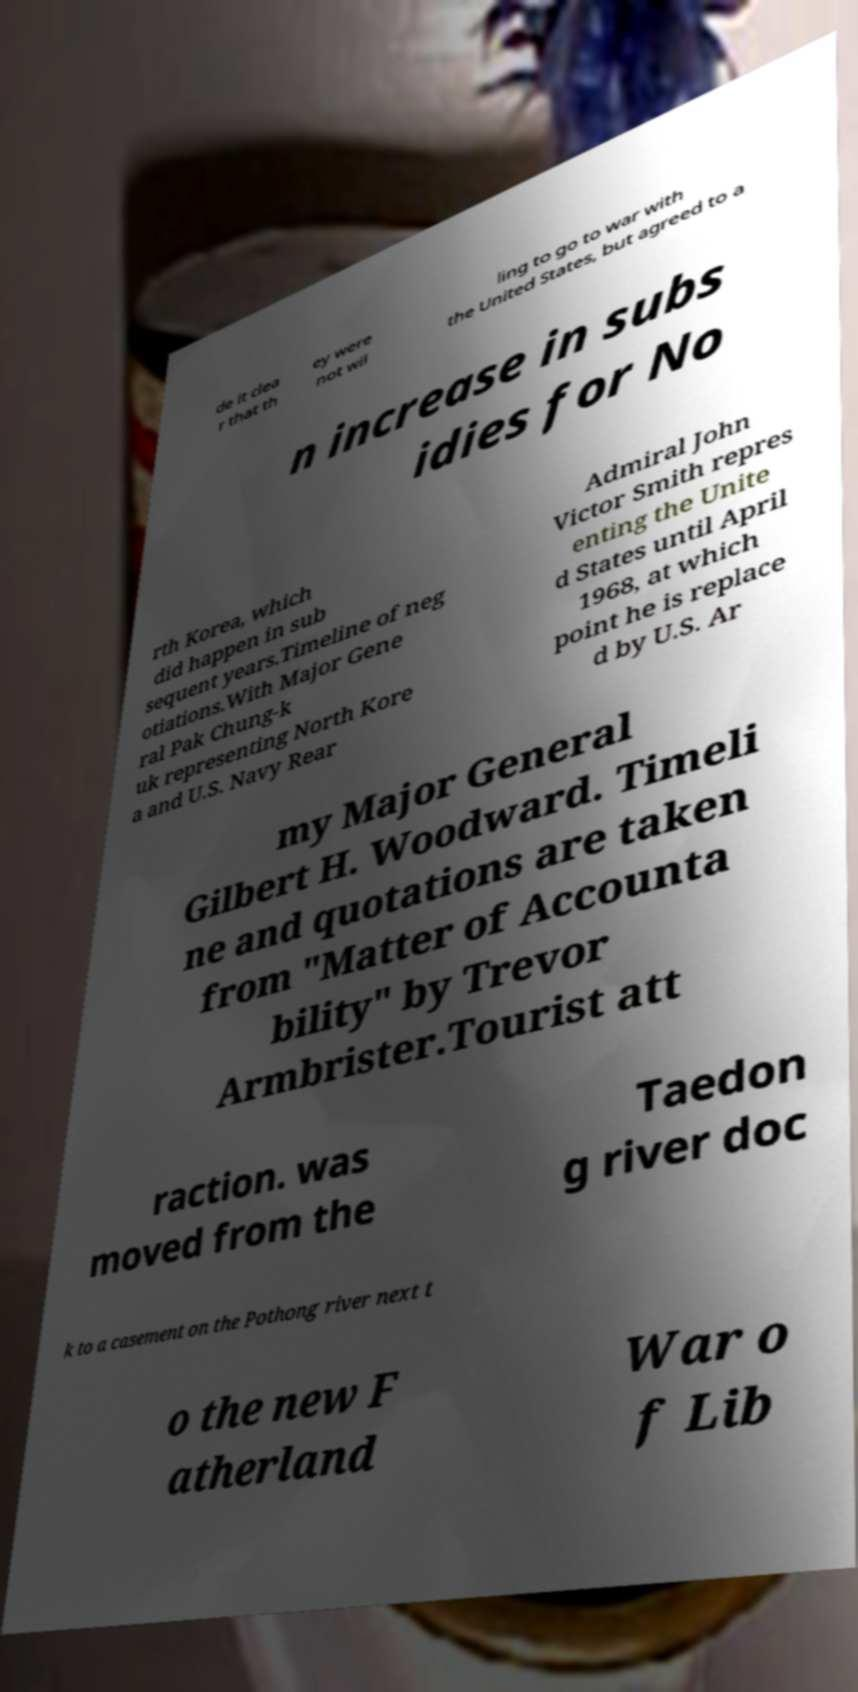Please read and relay the text visible in this image. What does it say? de it clea r that th ey were not wil ling to go to war with the United States, but agreed to a n increase in subs idies for No rth Korea, which did happen in sub sequent years.Timeline of neg otiations.With Major Gene ral Pak Chung-k uk representing North Kore a and U.S. Navy Rear Admiral John Victor Smith repres enting the Unite d States until April 1968, at which point he is replace d by U.S. Ar my Major General Gilbert H. Woodward. Timeli ne and quotations are taken from "Matter of Accounta bility" by Trevor Armbrister.Tourist att raction. was moved from the Taedon g river doc k to a casement on the Pothong river next t o the new F atherland War o f Lib 